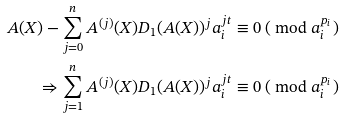Convert formula to latex. <formula><loc_0><loc_0><loc_500><loc_500>A ( X ) - \sum _ { j = 0 } ^ { n } { A ^ { ( j ) } ( X ) D _ { 1 } ( A ( X ) ) ^ { j } a _ { i } ^ { j t } } & \equiv 0 \ ( \text { mod } a _ { i } ^ { p _ { i } } ) \\ \Rightarrow \sum _ { j = 1 } ^ { n } { A ^ { ( j ) } ( X ) D _ { 1 } ( A ( X ) ) ^ { j } a _ { i } ^ { j t } } & \equiv 0 \ ( \text { mod } a _ { i } ^ { p _ { i } } )</formula> 